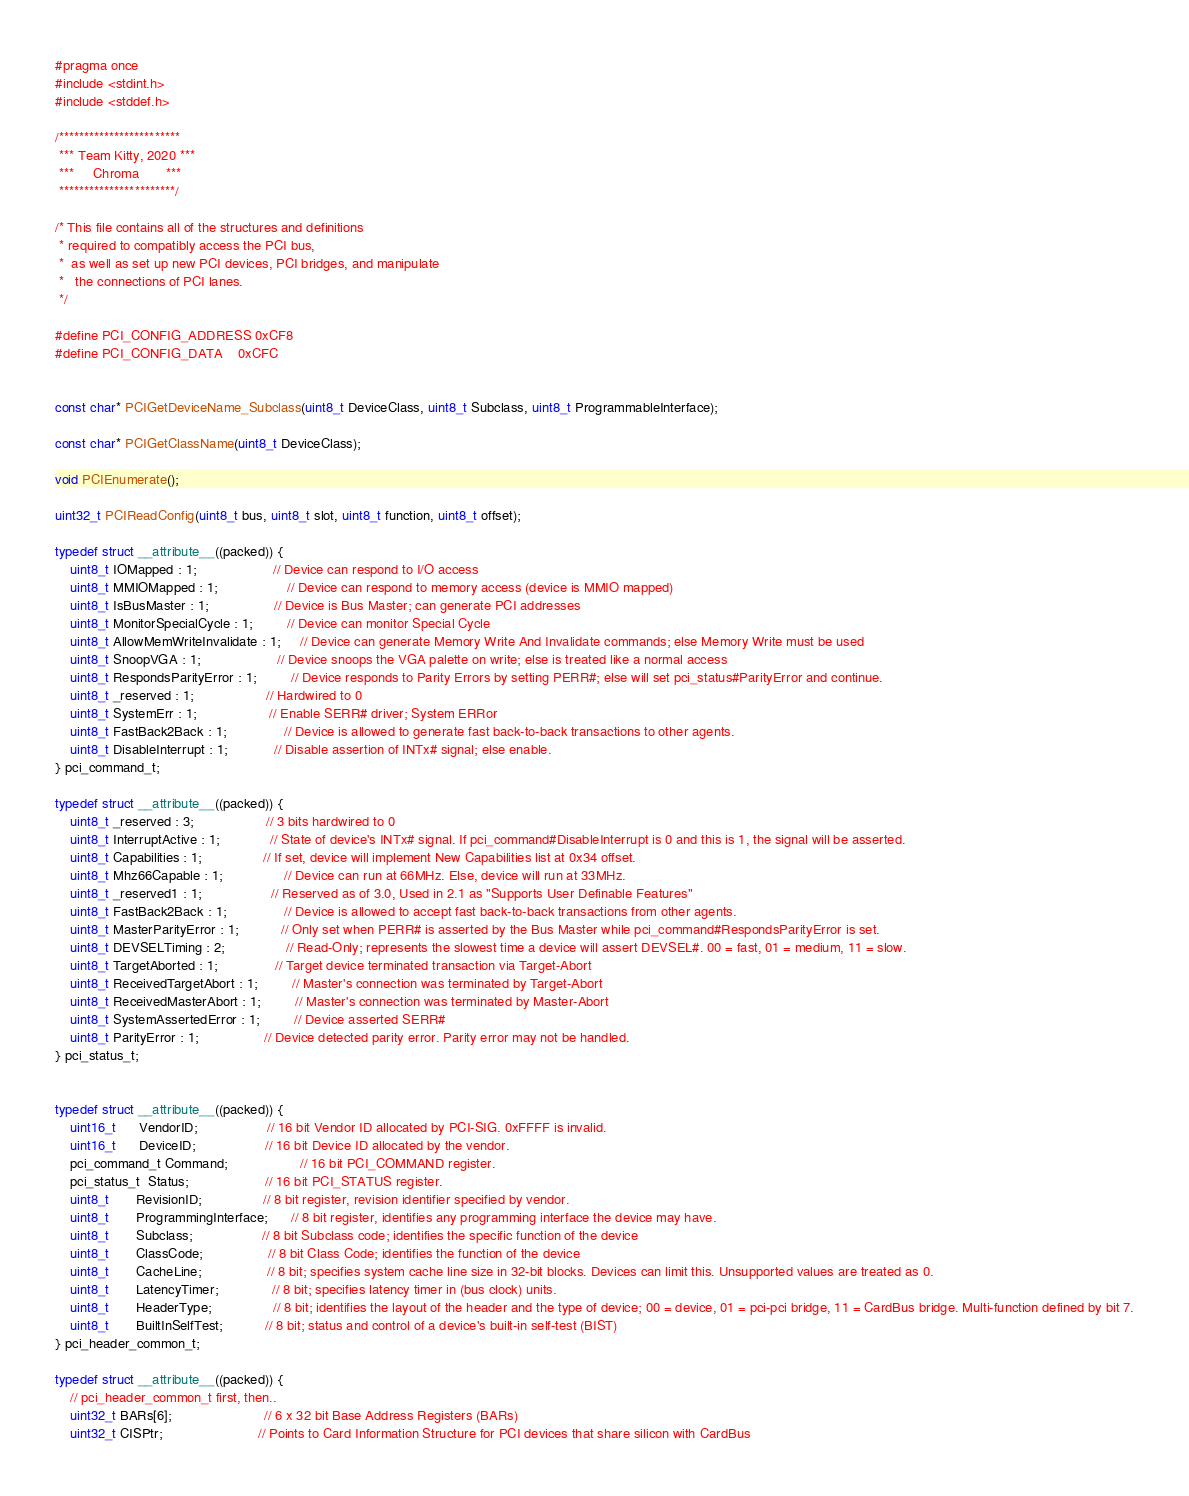<code> <loc_0><loc_0><loc_500><loc_500><_C_>#pragma once
#include <stdint.h>
#include <stddef.h>

/************************
 *** Team Kitty, 2020 ***
 ***     Chroma       ***
 ***********************/

/* This file contains all of the structures and definitions
 * required to compatibly access the PCI bus,
 *  as well as set up new PCI devices, PCI bridges, and manipulate
 *   the connections of PCI lanes.
 */

#define PCI_CONFIG_ADDRESS 0xCF8
#define PCI_CONFIG_DATA    0xCFC


const char* PCIGetDeviceName_Subclass(uint8_t DeviceClass, uint8_t Subclass, uint8_t ProgrammableInterface);

const char* PCIGetClassName(uint8_t DeviceClass);

void PCIEnumerate();

uint32_t PCIReadConfig(uint8_t bus, uint8_t slot, uint8_t function, uint8_t offset);

typedef struct __attribute__((packed)) {
    uint8_t IOMapped : 1;                    // Device can respond to I/O access
    uint8_t MMIOMapped : 1;                  // Device can respond to memory access (device is MMIO mapped)
    uint8_t IsBusMaster : 1;                 // Device is Bus Master; can generate PCI addresses
    uint8_t MonitorSpecialCycle : 1;         // Device can monitor Special Cycle
    uint8_t AllowMemWriteInvalidate : 1;     // Device can generate Memory Write And Invalidate commands; else Memory Write must be used
    uint8_t SnoopVGA : 1;                    // Device snoops the VGA palette on write; else is treated like a normal access
    uint8_t RespondsParityError : 1;         // Device responds to Parity Errors by setting PERR#; else will set pci_status#ParityError and continue.
    uint8_t _reserved : 1;                   // Hardwired to 0
    uint8_t SystemErr : 1;                   // Enable SERR# driver; System ERRor
    uint8_t FastBack2Back : 1;               // Device is allowed to generate fast back-to-back transactions to other agents.
    uint8_t DisableInterrupt : 1;            // Disable assertion of INTx# signal; else enable.
} pci_command_t;

typedef struct __attribute__((packed)) {
    uint8_t _reserved : 3;                   // 3 bits hardwired to 0   
    uint8_t InterruptActive : 1;             // State of device's INTx# signal. If pci_command#DisableInterrupt is 0 and this is 1, the signal will be asserted.
    uint8_t Capabilities : 1;                // If set, device will implement New Capabilities list at 0x34 offset.
    uint8_t Mhz66Capable : 1;                // Device can run at 66MHz. Else, device will run at 33MHz.
    uint8_t _reserved1 : 1;                  // Reserved as of 3.0, Used in 2.1 as "Supports User Definable Features"
    uint8_t FastBack2Back : 1;               // Device is allowed to accept fast back-to-back transactions from other agents.
    uint8_t MasterParityError : 1;           // Only set when PERR# is asserted by the Bus Master while pci_command#RespondsParityError is set.
    uint8_t DEVSELTiming : 2;                // Read-Only; represents the slowest time a device will assert DEVSEL#. 00 = fast, 01 = medium, 11 = slow.
    uint8_t TargetAborted : 1;               // Target device terminated transaction via Target-Abort
    uint8_t ReceivedTargetAbort : 1;         // Master's connection was terminated by Target-Abort
    uint8_t ReceivedMasterAbort : 1;         // Master's connection was terminated by Master-Abort
    uint8_t SystemAssertedError : 1;         // Device asserted SERR#
    uint8_t ParityError : 1;                 // Device detected parity error. Parity error may not be handled.
} pci_status_t;


typedef struct __attribute__((packed)) {
    uint16_t      VendorID;                  // 16 bit Vendor ID allocated by PCI-SIG. 0xFFFF is invalid.
    uint16_t      DeviceID;                  // 16 bit Device ID allocated by the vendor.
    pci_command_t Command;                   // 16 bit PCI_COMMAND register.
    pci_status_t  Status;                    // 16 bit PCI_STATUS register.
    uint8_t       RevisionID;                // 8 bit register, revision identifier specified by vendor.
    uint8_t       ProgrammingInterface;      // 8 bit register, identifies any programming interface the device may have.
    uint8_t       Subclass;                  // 8 bit Subclass code; identifies the specific function of the device
    uint8_t       ClassCode;                 // 8 bit Class Code; identifies the function of the device
    uint8_t       CacheLine;                 // 8 bit; specifies system cache line size in 32-bit blocks. Devices can limit this. Unsupported values are treated as 0.
    uint8_t       LatencyTimer;              // 8 bit; specifies latency timer in (bus clock) units.
    uint8_t       HeaderType;                // 8 bit; identifies the layout of the header and the type of device; 00 = device, 01 = pci-pci bridge, 11 = CardBus bridge. Multi-function defined by bit 7.
    uint8_t       BuiltInSelfTest;           // 8 bit; status and control of a device's built-in self-test (BIST)
} pci_header_common_t;

typedef struct __attribute__((packed)) {
    // pci_header_common_t first, then..
    uint32_t BARs[6];                        // 6 x 32 bit Base Address Registers (BARs)
    uint32_t CISPtr;                         // Points to Card Information Structure for PCI devices that share silicon with CardBus</code> 